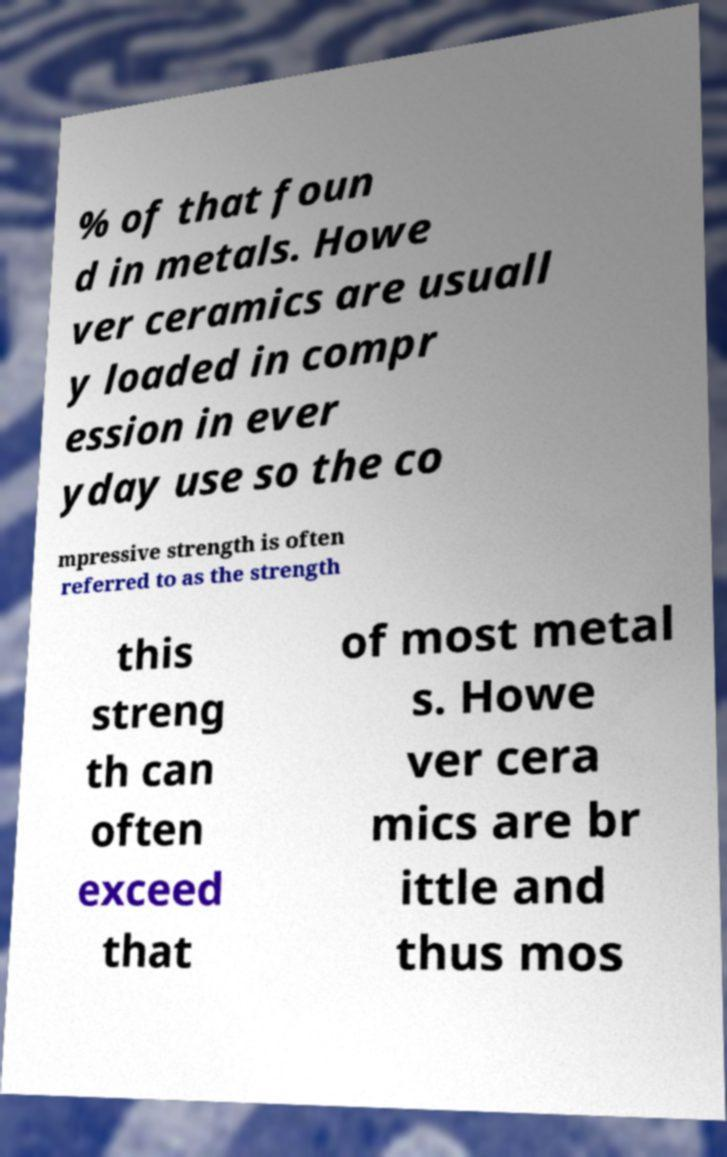I need the written content from this picture converted into text. Can you do that? % of that foun d in metals. Howe ver ceramics are usuall y loaded in compr ession in ever yday use so the co mpressive strength is often referred to as the strength this streng th can often exceed that of most metal s. Howe ver cera mics are br ittle and thus mos 